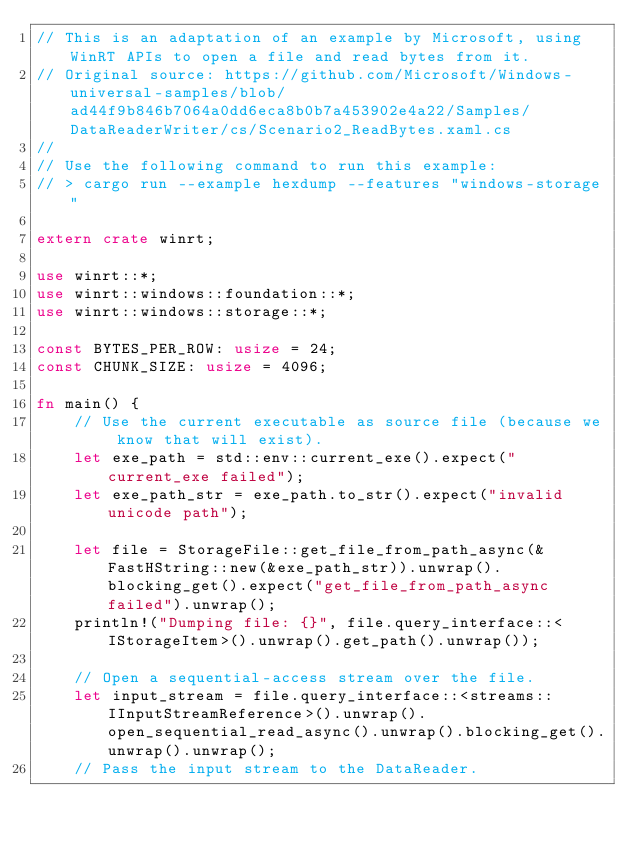<code> <loc_0><loc_0><loc_500><loc_500><_Rust_>// This is an adaptation of an example by Microsoft, using WinRT APIs to open a file and read bytes from it.
// Original source: https://github.com/Microsoft/Windows-universal-samples/blob/ad44f9b846b7064a0dd6eca8b0b7a453902e4a22/Samples/DataReaderWriter/cs/Scenario2_ReadBytes.xaml.cs
//
// Use the following command to run this example:
// > cargo run --example hexdump --features "windows-storage"

extern crate winrt;

use winrt::*;
use winrt::windows::foundation::*;
use winrt::windows::storage::*;

const BYTES_PER_ROW: usize = 24;
const CHUNK_SIZE: usize = 4096;

fn main() {
    // Use the current executable as source file (because we know that will exist).
    let exe_path = std::env::current_exe().expect("current_exe failed");
    let exe_path_str = exe_path.to_str().expect("invalid unicode path");

    let file = StorageFile::get_file_from_path_async(&FastHString::new(&exe_path_str)).unwrap().blocking_get().expect("get_file_from_path_async failed").unwrap();
    println!("Dumping file: {}", file.query_interface::<IStorageItem>().unwrap().get_path().unwrap());

    // Open a sequential-access stream over the file.
    let input_stream = file.query_interface::<streams::IInputStreamReference>().unwrap().open_sequential_read_async().unwrap().blocking_get().unwrap().unwrap();
    // Pass the input stream to the DataReader.</code> 